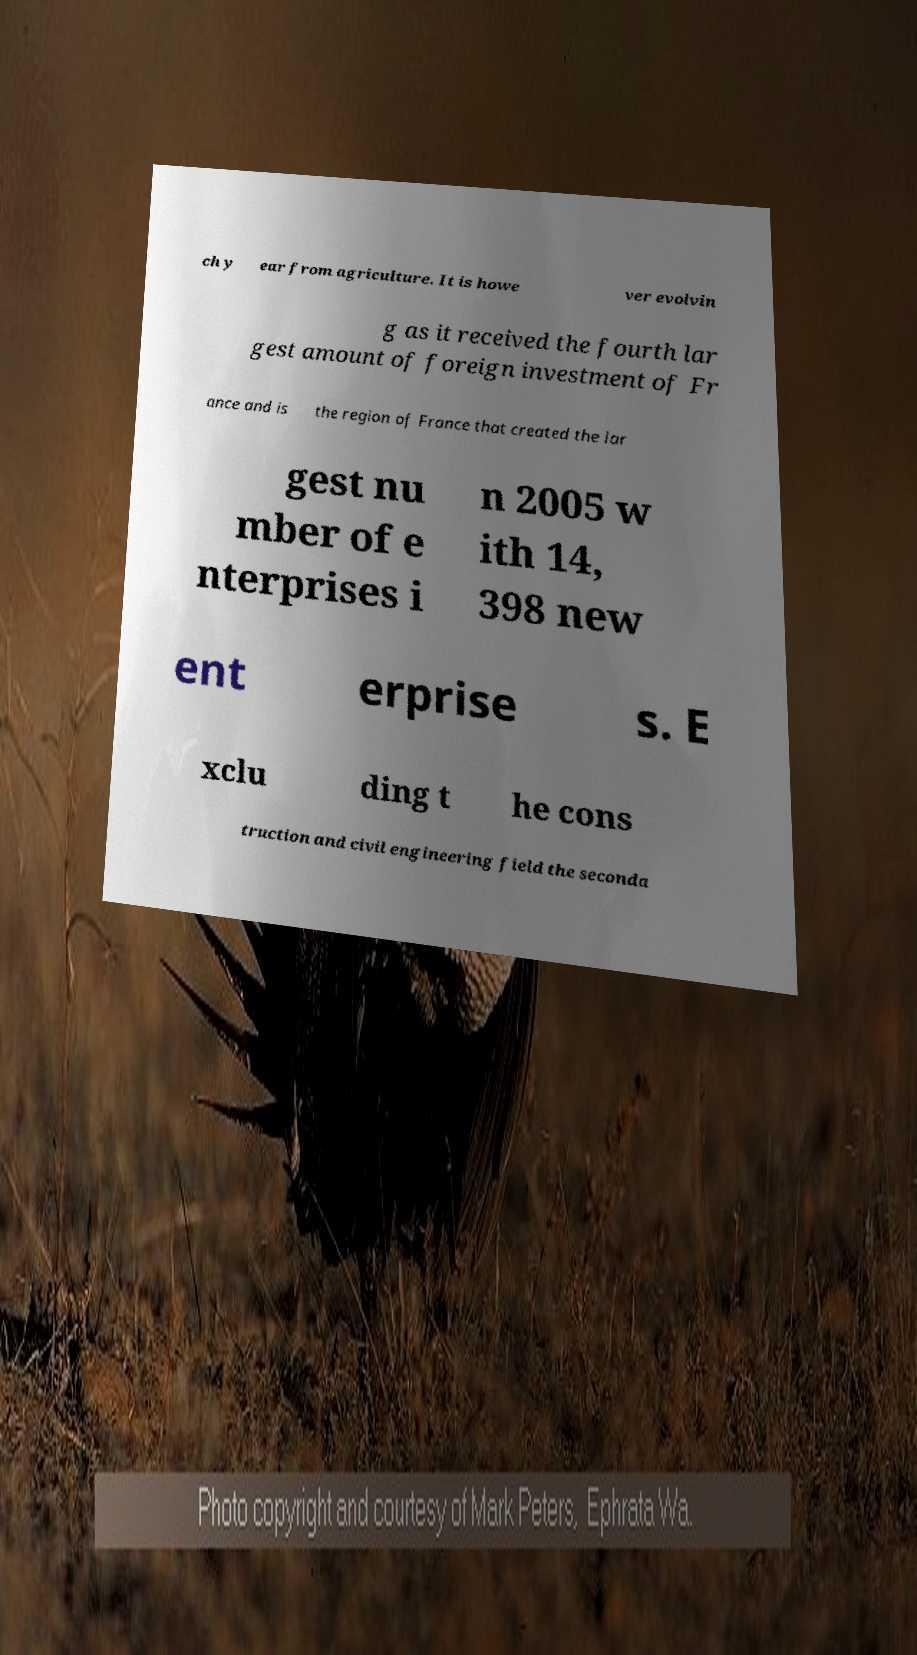What messages or text are displayed in this image? I need them in a readable, typed format. ch y ear from agriculture. It is howe ver evolvin g as it received the fourth lar gest amount of foreign investment of Fr ance and is the region of France that created the lar gest nu mber of e nterprises i n 2005 w ith 14, 398 new ent erprise s. E xclu ding t he cons truction and civil engineering field the seconda 